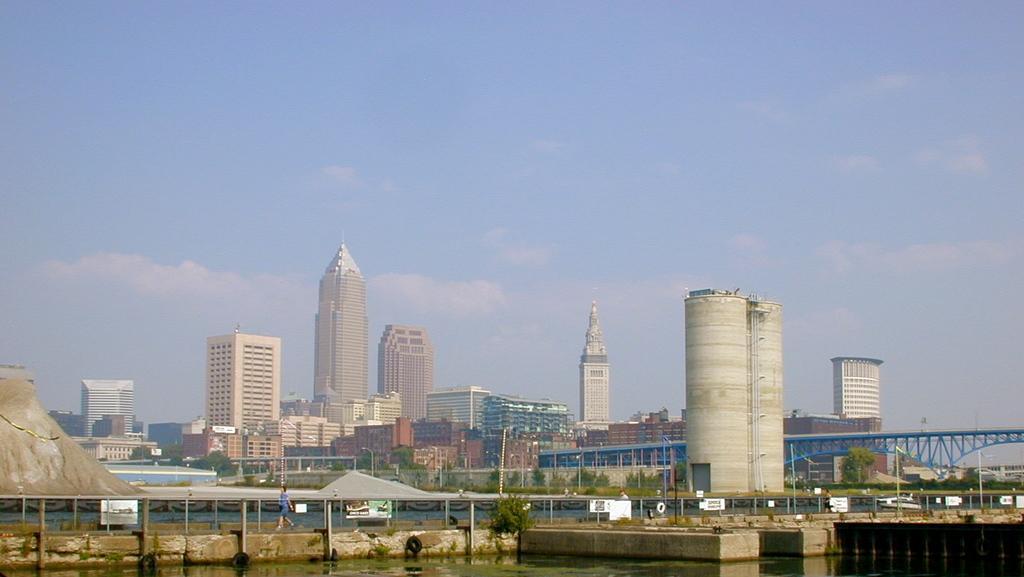Can you describe this image briefly? In this picture I can observe some buildings. There is a river. On the right side I can observe a bridge over the river. In the background I can observe some clouds in the sky. 